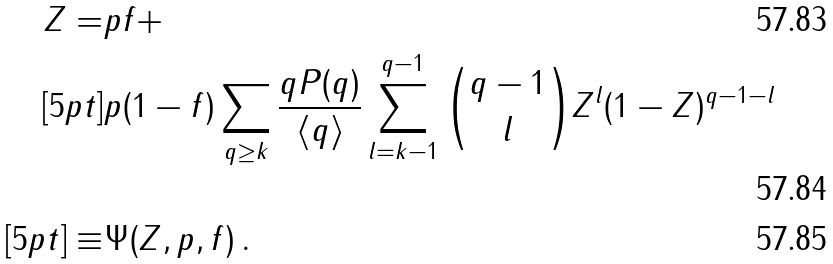Convert formula to latex. <formula><loc_0><loc_0><loc_500><loc_500>Z = & p f + \\ [ 5 p t ] & p ( 1 - f ) \sum _ { q \geq k } \frac { q P ( q ) } { \langle q \rangle } \sum _ { l = k - 1 } ^ { q - 1 } \binom { q - 1 } { l } Z ^ { l } ( 1 - Z ) ^ { q - 1 - l } \\ [ 5 p t ] \equiv & \Psi ( Z , p , f ) \, .</formula> 